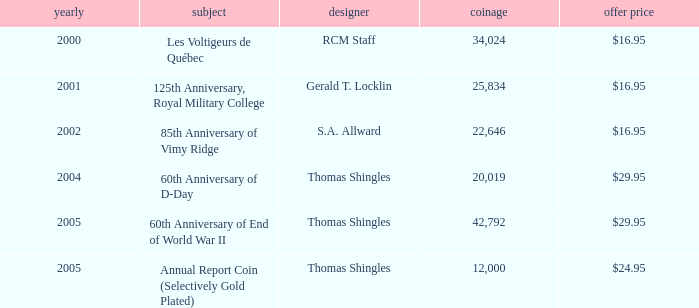What was the total mintage for years after 2002 that had a 85th Anniversary of Vimy Ridge theme? 0.0. 